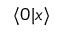Convert formula to latex. <formula><loc_0><loc_0><loc_500><loc_500>\langle 0 | x \rangle</formula> 